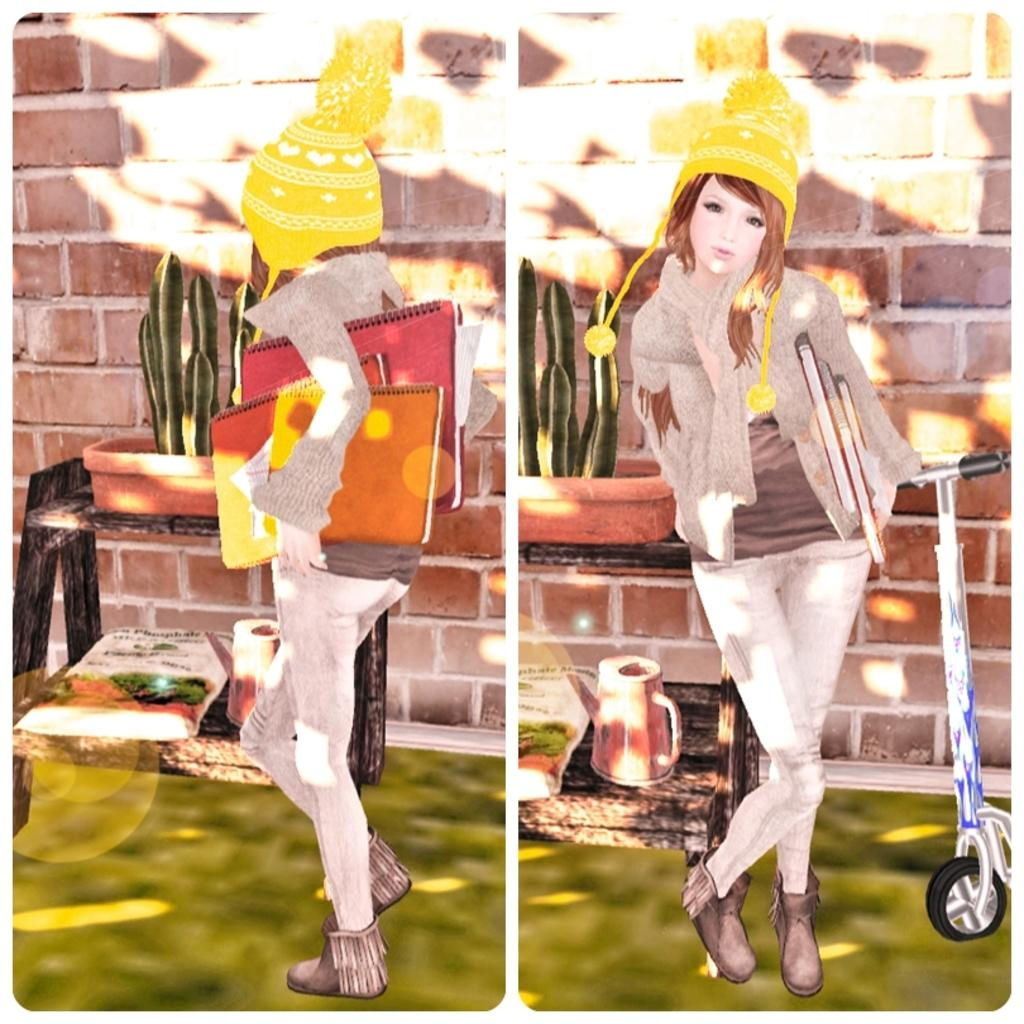What is the format of the image? The image is a collage of two depictions. What statement does the sidewalk make in the image? There is no sidewalk present in the image, as it is a collage of two depictions. How many times is the paper folded in the image? There is no paper present in the image, as it is a collage of two depictions. 